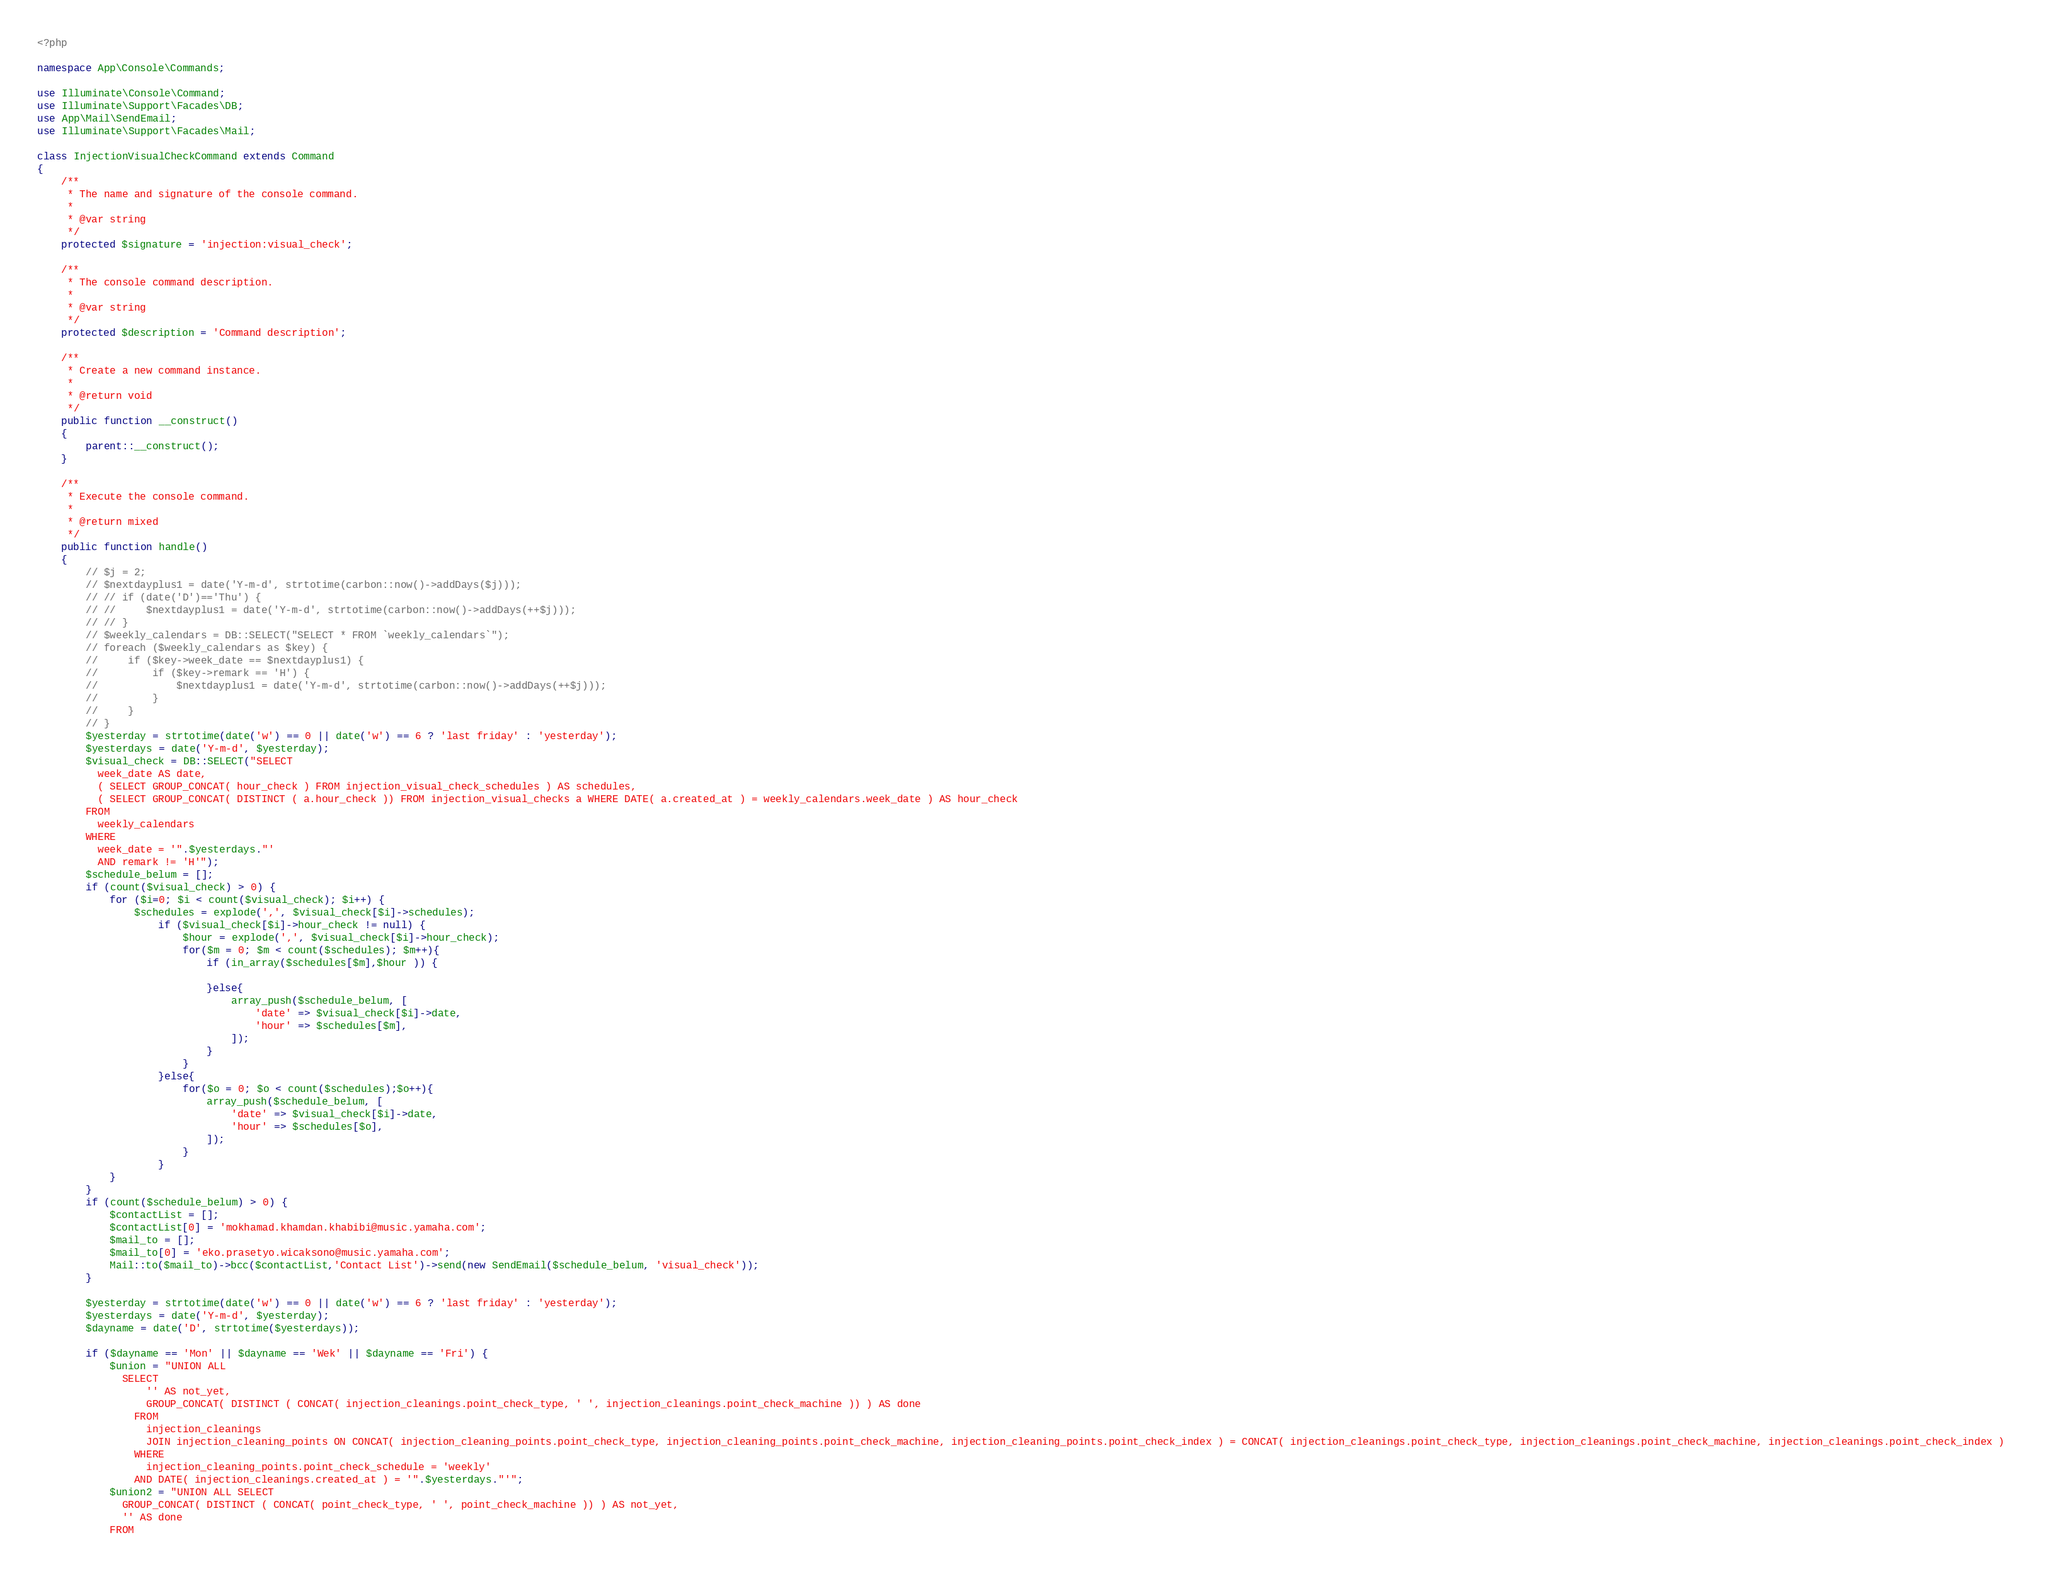<code> <loc_0><loc_0><loc_500><loc_500><_PHP_><?php

namespace App\Console\Commands;

use Illuminate\Console\Command;
use Illuminate\Support\Facades\DB;
use App\Mail\SendEmail;
use Illuminate\Support\Facades\Mail;

class InjectionVisualCheckCommand extends Command
{
    /**
     * The name and signature of the console command.
     *
     * @var string
     */
    protected $signature = 'injection:visual_check';

    /**
     * The console command description.
     *
     * @var string
     */
    protected $description = 'Command description';

    /**
     * Create a new command instance.
     *
     * @return void
     */
    public function __construct()
    {
        parent::__construct();
    }

    /**
     * Execute the console command.
     *
     * @return mixed
     */
    public function handle()
    {
        // $j = 2;
        // $nextdayplus1 = date('Y-m-d', strtotime(carbon::now()->addDays($j)));
        // // if (date('D')=='Thu') {
        // //     $nextdayplus1 = date('Y-m-d', strtotime(carbon::now()->addDays(++$j)));
        // // }
        // $weekly_calendars = DB::SELECT("SELECT * FROM `weekly_calendars`");
        // foreach ($weekly_calendars as $key) {
        //     if ($key->week_date == $nextdayplus1) {
        //         if ($key->remark == 'H') {
        //             $nextdayplus1 = date('Y-m-d', strtotime(carbon::now()->addDays(++$j)));
        //         }
        //     }
        // }
        $yesterday = strtotime(date('w') == 0 || date('w') == 6 ? 'last friday' : 'yesterday');
        $yesterdays = date('Y-m-d', $yesterday);
        $visual_check = DB::SELECT("SELECT
          week_date AS date,
          ( SELECT GROUP_CONCAT( hour_check ) FROM injection_visual_check_schedules ) AS schedules,
          ( SELECT GROUP_CONCAT( DISTINCT ( a.hour_check )) FROM injection_visual_checks a WHERE DATE( a.created_at ) = weekly_calendars.week_date ) AS hour_check 
        FROM
          weekly_calendars 
        WHERE
          week_date = '".$yesterdays."'
          AND remark != 'H'");
        $schedule_belum = [];
        if (count($visual_check) > 0) {
            for ($i=0; $i < count($visual_check); $i++) { 
                $schedules = explode(',', $visual_check[$i]->schedules);
                    if ($visual_check[$i]->hour_check != null) {
                        $hour = explode(',', $visual_check[$i]->hour_check);
                        for($m = 0; $m < count($schedules); $m++){
                            if (in_array($schedules[$m],$hour )) {

                            }else{
                                array_push($schedule_belum, [
                                    'date' => $visual_check[$i]->date,
                                    'hour' => $schedules[$m],
                                ]);
                            }
                        }
                    }else{
                        for($o = 0; $o < count($schedules);$o++){
                            array_push($schedule_belum, [
                                'date' => $visual_check[$i]->date,
                                'hour' => $schedules[$o],
                            ]);
                        }
                    }
            }
        }
        if (count($schedule_belum) > 0) {
            $contactList = [];
            $contactList[0] = 'mokhamad.khamdan.khabibi@music.yamaha.com';
            $mail_to = [];
            $mail_to[0] = 'eko.prasetyo.wicaksono@music.yamaha.com';
            Mail::to($mail_to)->bcc($contactList,'Contact List')->send(new SendEmail($schedule_belum, 'visual_check'));
        }

        $yesterday = strtotime(date('w') == 0 || date('w') == 6 ? 'last friday' : 'yesterday');
        $yesterdays = date('Y-m-d', $yesterday);
        $dayname = date('D', strtotime($yesterdays));

        if ($dayname == 'Mon' || $dayname == 'Wek' || $dayname == 'Fri') {
            $union = "UNION ALL
              SELECT
                  '' AS not_yet,
                  GROUP_CONCAT( DISTINCT ( CONCAT( injection_cleanings.point_check_type, ' ', injection_cleanings.point_check_machine )) ) AS done 
                FROM
                  injection_cleanings
                  JOIN injection_cleaning_points ON CONCAT( injection_cleaning_points.point_check_type, injection_cleaning_points.point_check_machine, injection_cleaning_points.point_check_index ) = CONCAT( injection_cleanings.point_check_type, injection_cleanings.point_check_machine, injection_cleanings.point_check_index ) 
                WHERE
                  injection_cleaning_points.point_check_schedule = 'weekly' 
                AND DATE( injection_cleanings.created_at ) = '".$yesterdays."'";
            $union2 = "UNION ALL SELECT
              GROUP_CONCAT( DISTINCT ( CONCAT( point_check_type, ' ', point_check_machine )) ) AS not_yet,
              '' AS done 
            FROM</code> 